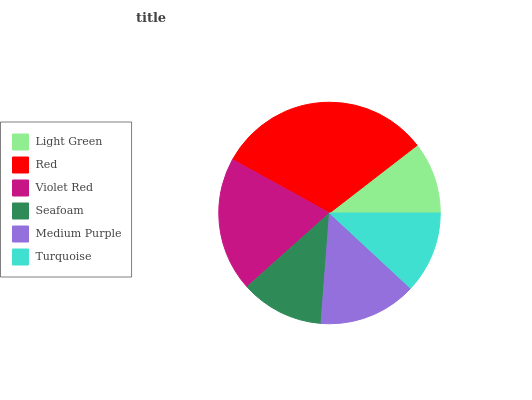Is Light Green the minimum?
Answer yes or no. Yes. Is Red the maximum?
Answer yes or no. Yes. Is Violet Red the minimum?
Answer yes or no. No. Is Violet Red the maximum?
Answer yes or no. No. Is Red greater than Violet Red?
Answer yes or no. Yes. Is Violet Red less than Red?
Answer yes or no. Yes. Is Violet Red greater than Red?
Answer yes or no. No. Is Red less than Violet Red?
Answer yes or no. No. Is Medium Purple the high median?
Answer yes or no. Yes. Is Seafoam the low median?
Answer yes or no. Yes. Is Violet Red the high median?
Answer yes or no. No. Is Red the low median?
Answer yes or no. No. 